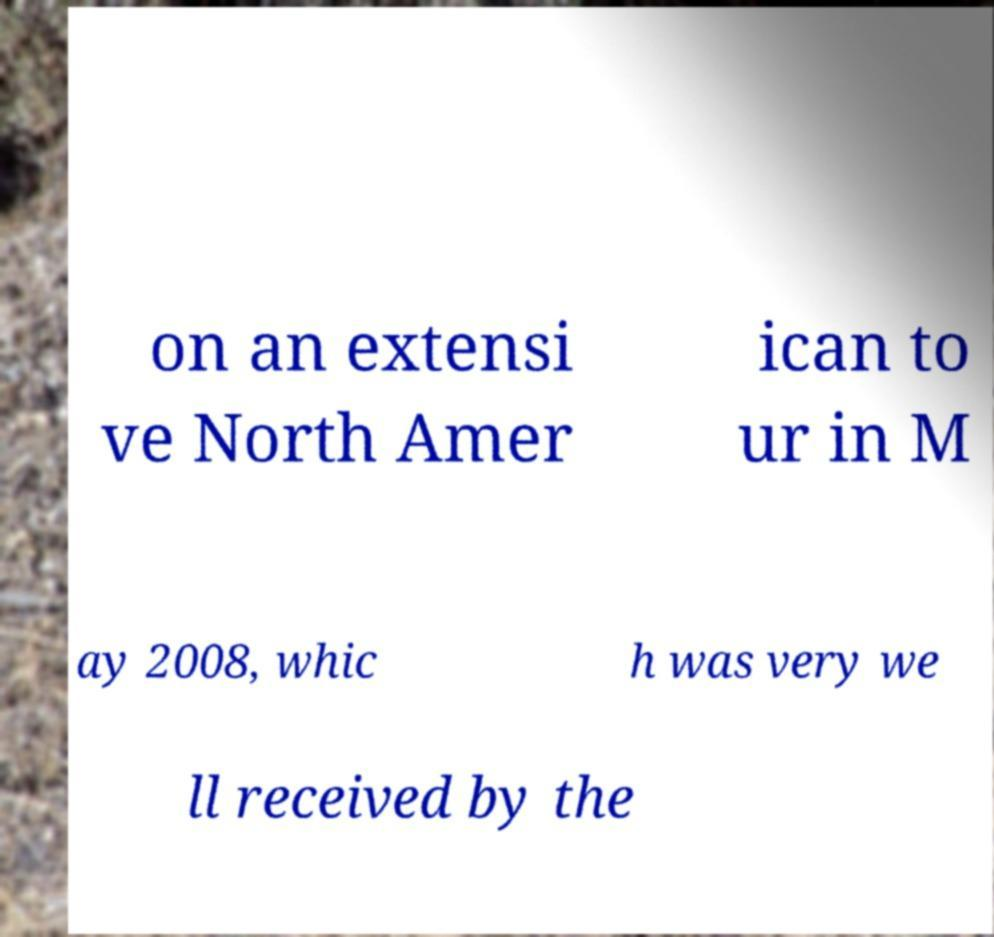Can you read and provide the text displayed in the image?This photo seems to have some interesting text. Can you extract and type it out for me? on an extensi ve North Amer ican to ur in M ay 2008, whic h was very we ll received by the 